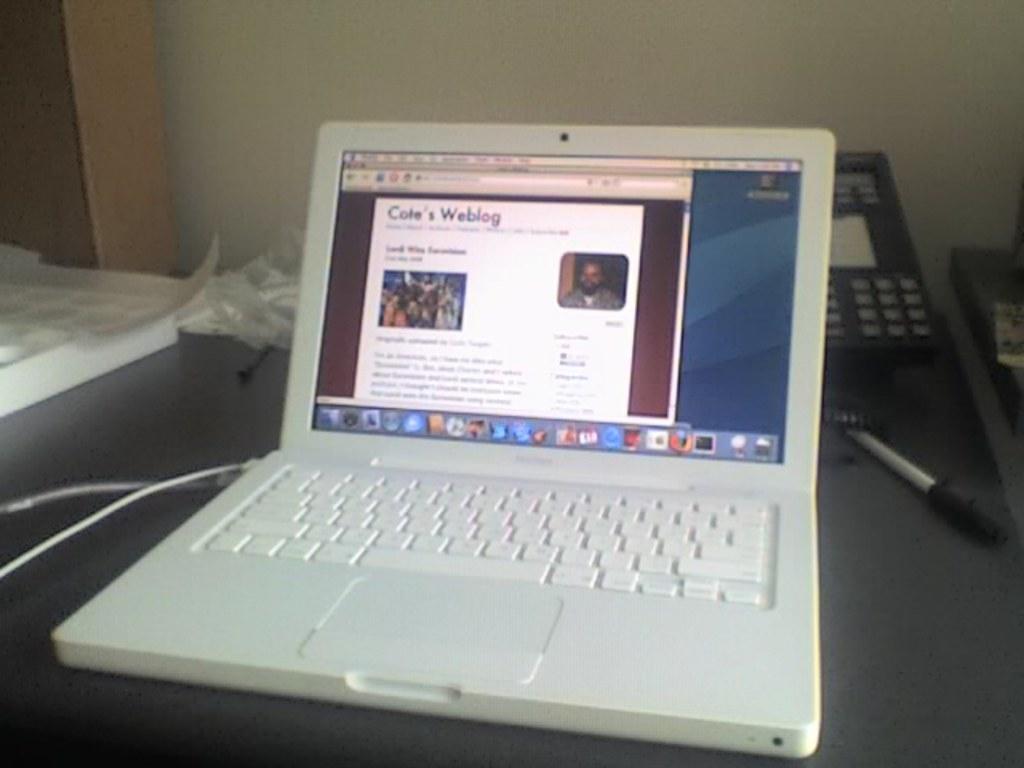Who's blog is shown on the screen?
Offer a very short reply. Cole's. 